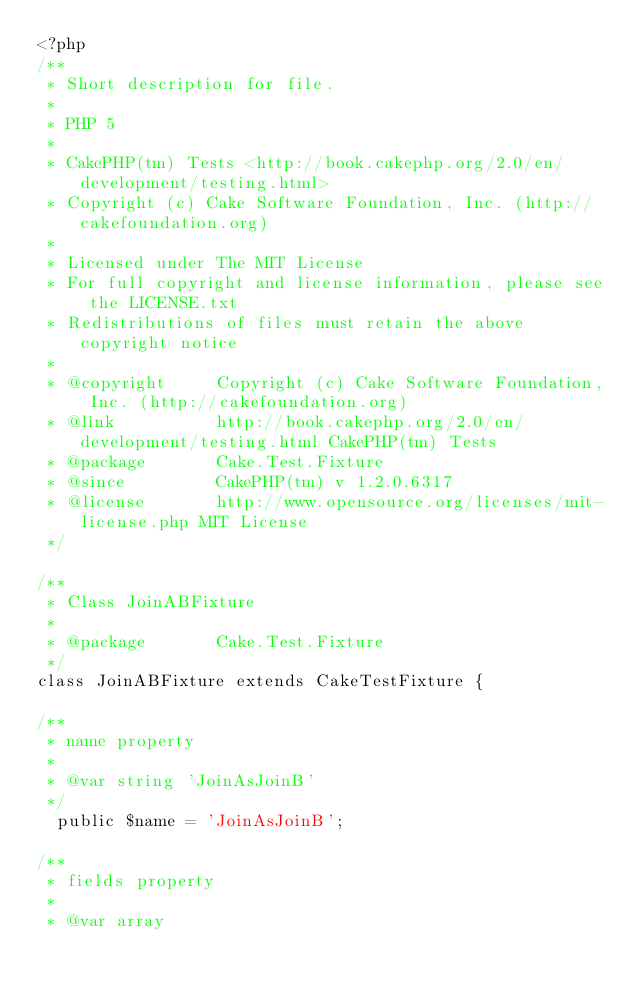<code> <loc_0><loc_0><loc_500><loc_500><_PHP_><?php
/**
 * Short description for file.
 *
 * PHP 5
 *
 * CakePHP(tm) Tests <http://book.cakephp.org/2.0/en/development/testing.html>
 * Copyright (c) Cake Software Foundation, Inc. (http://cakefoundation.org)
 *
 * Licensed under The MIT License
 * For full copyright and license information, please see the LICENSE.txt
 * Redistributions of files must retain the above copyright notice
 *
 * @copyright     Copyright (c) Cake Software Foundation, Inc. (http://cakefoundation.org)
 * @link          http://book.cakephp.org/2.0/en/development/testing.html CakePHP(tm) Tests
 * @package       Cake.Test.Fixture
 * @since         CakePHP(tm) v 1.2.0.6317
 * @license       http://www.opensource.org/licenses/mit-license.php MIT License
 */

/**
 * Class JoinABFixture
 *
 * @package       Cake.Test.Fixture
 */
class JoinABFixture extends CakeTestFixture {

/**
 * name property
 *
 * @var string 'JoinAsJoinB'
 */
	public $name = 'JoinAsJoinB';

/**
 * fields property
 *
 * @var array</code> 